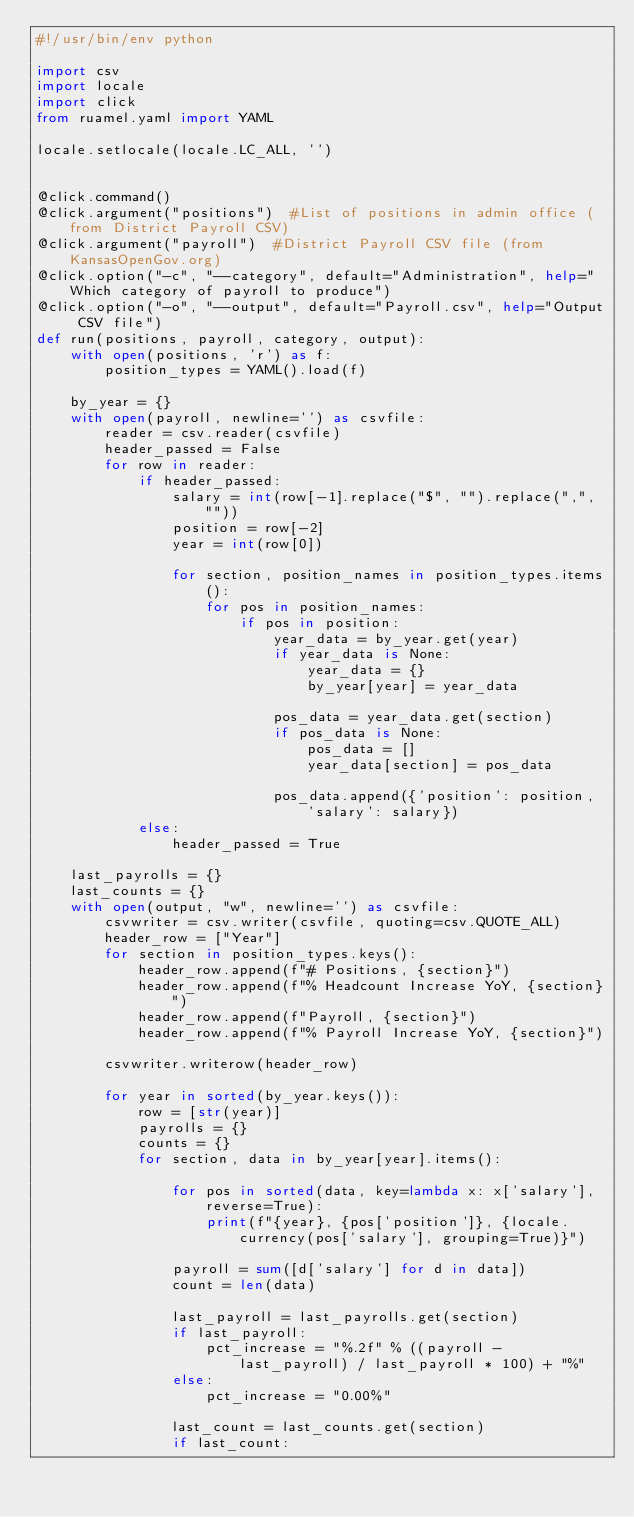<code> <loc_0><loc_0><loc_500><loc_500><_Python_>#!/usr/bin/env python

import csv
import locale
import click
from ruamel.yaml import YAML

locale.setlocale(locale.LC_ALL, '')


@click.command()
@click.argument("positions")  #List of positions in admin office (from District Payroll CSV)
@click.argument("payroll")  #District Payroll CSV file (from KansasOpenGov.org)
@click.option("-c", "--category", default="Administration", help="Which category of payroll to produce")
@click.option("-o", "--output", default="Payroll.csv", help="Output CSV file")
def run(positions, payroll, category, output):
    with open(positions, 'r') as f:
        position_types = YAML().load(f)

    by_year = {}
    with open(payroll, newline='') as csvfile:
        reader = csv.reader(csvfile)
        header_passed = False
        for row in reader:
            if header_passed:
                salary = int(row[-1].replace("$", "").replace(",", ""))
                position = row[-2]
                year = int(row[0])

                for section, position_names in position_types.items():
                    for pos in position_names:
                        if pos in position:
                            year_data = by_year.get(year)
                            if year_data is None:
                                year_data = {}
                                by_year[year] = year_data

                            pos_data = year_data.get(section)
                            if pos_data is None:
                                pos_data = []
                                year_data[section] = pos_data

                            pos_data.append({'position': position, 'salary': salary})
            else:
                header_passed = True

    last_payrolls = {}
    last_counts = {}
    with open(output, "w", newline='') as csvfile:
        csvwriter = csv.writer(csvfile, quoting=csv.QUOTE_ALL)
        header_row = ["Year"]
        for section in position_types.keys():
            header_row.append(f"# Positions, {section}")
            header_row.append(f"% Headcount Increase YoY, {section}")
            header_row.append(f"Payroll, {section}")
            header_row.append(f"% Payroll Increase YoY, {section}")

        csvwriter.writerow(header_row)

        for year in sorted(by_year.keys()):
            row = [str(year)]
            payrolls = {}
            counts = {}
            for section, data in by_year[year].items():

                for pos in sorted(data, key=lambda x: x['salary'], reverse=True):
                    print(f"{year}, {pos['position']}, {locale.currency(pos['salary'], grouping=True)}")

                payroll = sum([d['salary'] for d in data])
                count = len(data)

                last_payroll = last_payrolls.get(section)
                if last_payroll:
                    pct_increase = "%.2f" % ((payroll - last_payroll) / last_payroll * 100) + "%"
                else:
                    pct_increase = "0.00%"

                last_count = last_counts.get(section)
                if last_count:</code> 